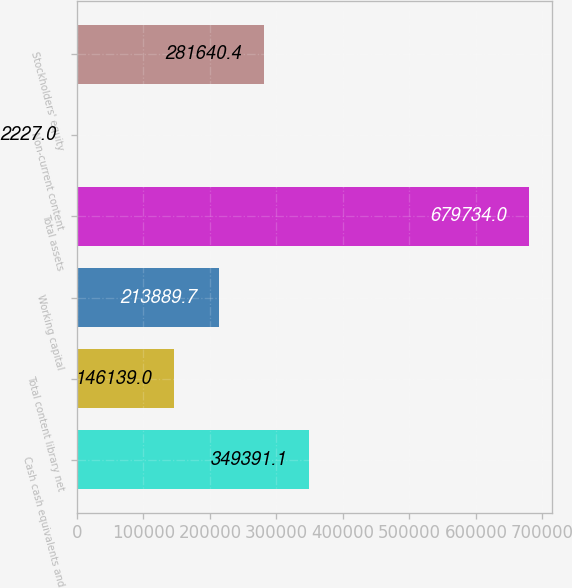<chart> <loc_0><loc_0><loc_500><loc_500><bar_chart><fcel>Cash cash equivalents and<fcel>Total content library net<fcel>Working capital<fcel>Total assets<fcel>Non-current content<fcel>Stockholders' equity<nl><fcel>349391<fcel>146139<fcel>213890<fcel>679734<fcel>2227<fcel>281640<nl></chart> 